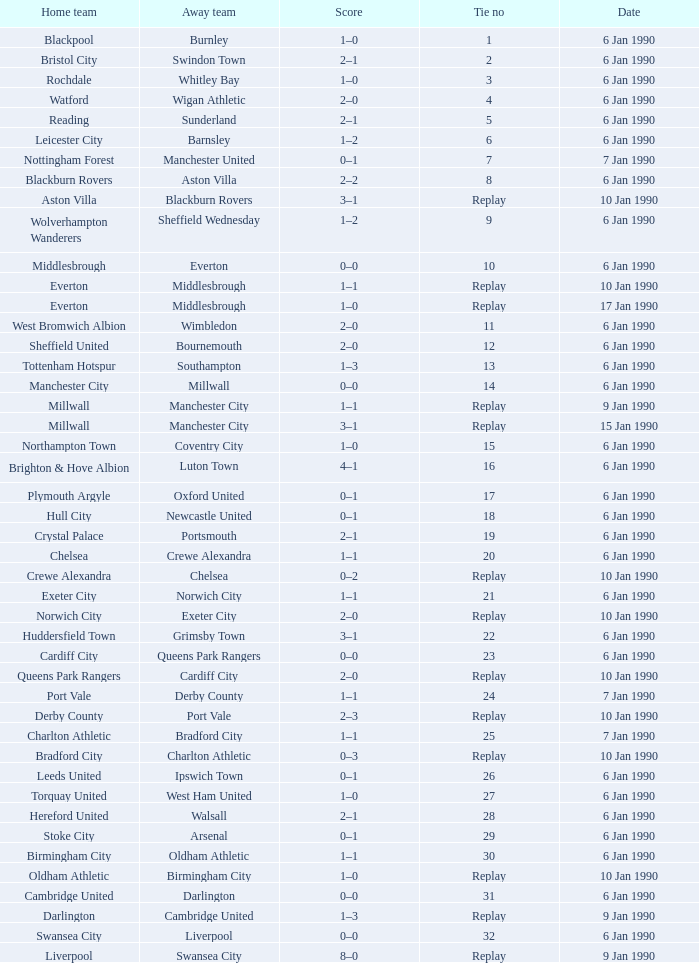Could you help me parse every detail presented in this table? {'header': ['Home team', 'Away team', 'Score', 'Tie no', 'Date'], 'rows': [['Blackpool', 'Burnley', '1–0', '1', '6 Jan 1990'], ['Bristol City', 'Swindon Town', '2–1', '2', '6 Jan 1990'], ['Rochdale', 'Whitley Bay', '1–0', '3', '6 Jan 1990'], ['Watford', 'Wigan Athletic', '2–0', '4', '6 Jan 1990'], ['Reading', 'Sunderland', '2–1', '5', '6 Jan 1990'], ['Leicester City', 'Barnsley', '1–2', '6', '6 Jan 1990'], ['Nottingham Forest', 'Manchester United', '0–1', '7', '7 Jan 1990'], ['Blackburn Rovers', 'Aston Villa', '2–2', '8', '6 Jan 1990'], ['Aston Villa', 'Blackburn Rovers', '3–1', 'Replay', '10 Jan 1990'], ['Wolverhampton Wanderers', 'Sheffield Wednesday', '1–2', '9', '6 Jan 1990'], ['Middlesbrough', 'Everton', '0–0', '10', '6 Jan 1990'], ['Everton', 'Middlesbrough', '1–1', 'Replay', '10 Jan 1990'], ['Everton', 'Middlesbrough', '1–0', 'Replay', '17 Jan 1990'], ['West Bromwich Albion', 'Wimbledon', '2–0', '11', '6 Jan 1990'], ['Sheffield United', 'Bournemouth', '2–0', '12', '6 Jan 1990'], ['Tottenham Hotspur', 'Southampton', '1–3', '13', '6 Jan 1990'], ['Manchester City', 'Millwall', '0–0', '14', '6 Jan 1990'], ['Millwall', 'Manchester City', '1–1', 'Replay', '9 Jan 1990'], ['Millwall', 'Manchester City', '3–1', 'Replay', '15 Jan 1990'], ['Northampton Town', 'Coventry City', '1–0', '15', '6 Jan 1990'], ['Brighton & Hove Albion', 'Luton Town', '4–1', '16', '6 Jan 1990'], ['Plymouth Argyle', 'Oxford United', '0–1', '17', '6 Jan 1990'], ['Hull City', 'Newcastle United', '0–1', '18', '6 Jan 1990'], ['Crystal Palace', 'Portsmouth', '2–1', '19', '6 Jan 1990'], ['Chelsea', 'Crewe Alexandra', '1–1', '20', '6 Jan 1990'], ['Crewe Alexandra', 'Chelsea', '0–2', 'Replay', '10 Jan 1990'], ['Exeter City', 'Norwich City', '1–1', '21', '6 Jan 1990'], ['Norwich City', 'Exeter City', '2–0', 'Replay', '10 Jan 1990'], ['Huddersfield Town', 'Grimsby Town', '3–1', '22', '6 Jan 1990'], ['Cardiff City', 'Queens Park Rangers', '0–0', '23', '6 Jan 1990'], ['Queens Park Rangers', 'Cardiff City', '2–0', 'Replay', '10 Jan 1990'], ['Port Vale', 'Derby County', '1–1', '24', '7 Jan 1990'], ['Derby County', 'Port Vale', '2–3', 'Replay', '10 Jan 1990'], ['Charlton Athletic', 'Bradford City', '1–1', '25', '7 Jan 1990'], ['Bradford City', 'Charlton Athletic', '0–3', 'Replay', '10 Jan 1990'], ['Leeds United', 'Ipswich Town', '0–1', '26', '6 Jan 1990'], ['Torquay United', 'West Ham United', '1–0', '27', '6 Jan 1990'], ['Hereford United', 'Walsall', '2–1', '28', '6 Jan 1990'], ['Stoke City', 'Arsenal', '0–1', '29', '6 Jan 1990'], ['Birmingham City', 'Oldham Athletic', '1–1', '30', '6 Jan 1990'], ['Oldham Athletic', 'Birmingham City', '1–0', 'Replay', '10 Jan 1990'], ['Cambridge United', 'Darlington', '0–0', '31', '6 Jan 1990'], ['Darlington', 'Cambridge United', '1–3', 'Replay', '9 Jan 1990'], ['Swansea City', 'Liverpool', '0–0', '32', '6 Jan 1990'], ['Liverpool', 'Swansea City', '8–0', 'Replay', '9 Jan 1990']]} What date did home team liverpool play? 9 Jan 1990. 